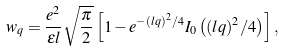<formula> <loc_0><loc_0><loc_500><loc_500>w _ { q } = \frac { e ^ { 2 } } { \epsilon l } \sqrt { \frac { \pi } { 2 } } \left [ 1 - e ^ { - ( l q ) ^ { 2 } / 4 } I _ { 0 } \left ( ( l q ) ^ { 2 } / 4 \right ) \right ] ,</formula> 